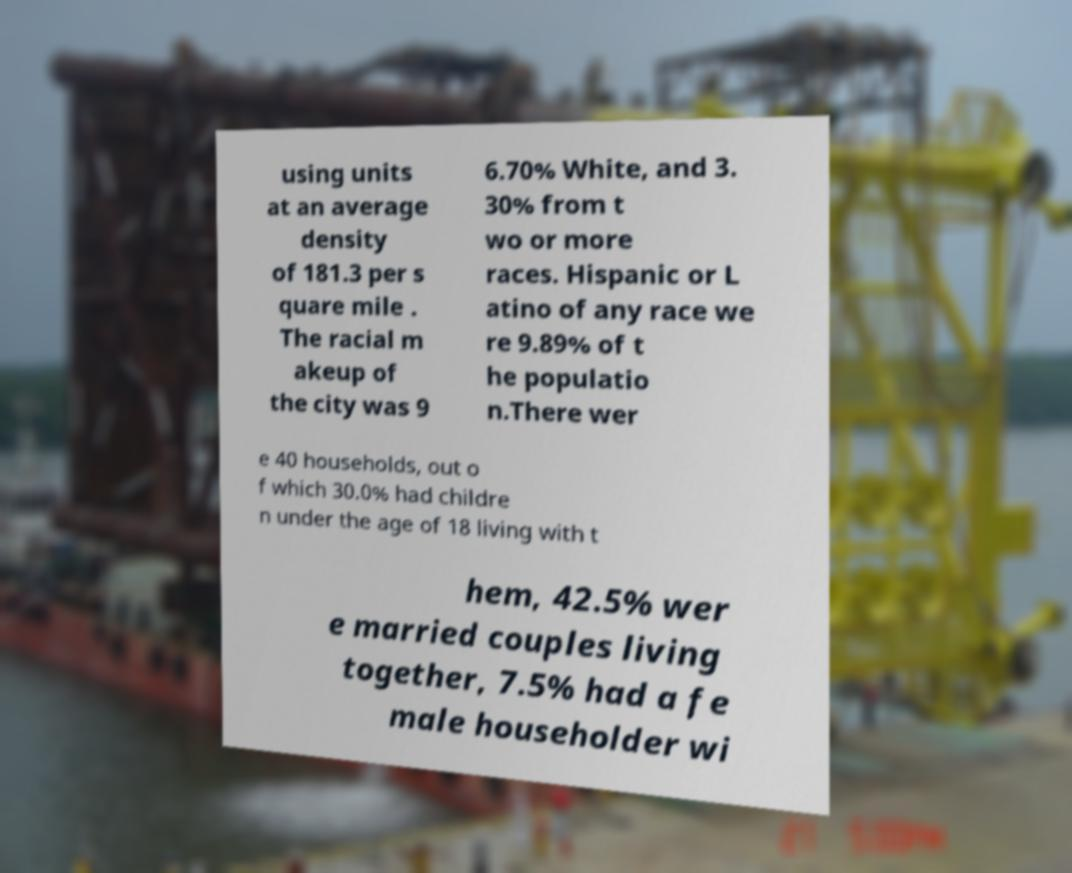Can you read and provide the text displayed in the image?This photo seems to have some interesting text. Can you extract and type it out for me? using units at an average density of 181.3 per s quare mile . The racial m akeup of the city was 9 6.70% White, and 3. 30% from t wo or more races. Hispanic or L atino of any race we re 9.89% of t he populatio n.There wer e 40 households, out o f which 30.0% had childre n under the age of 18 living with t hem, 42.5% wer e married couples living together, 7.5% had a fe male householder wi 